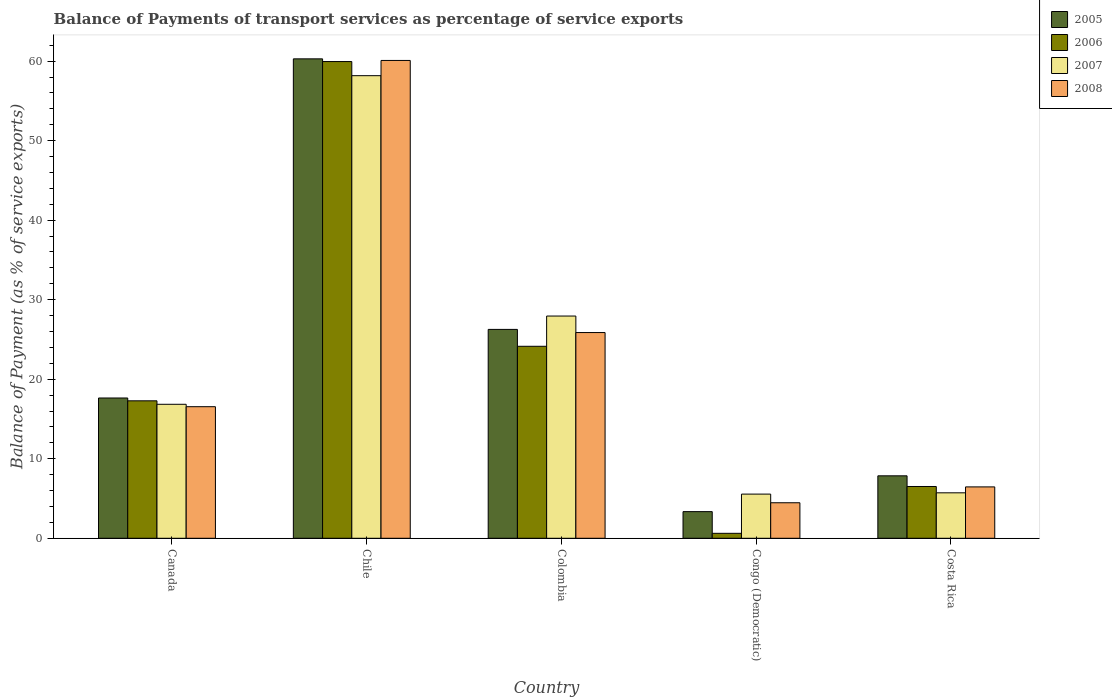How many different coloured bars are there?
Your answer should be very brief. 4. Are the number of bars per tick equal to the number of legend labels?
Keep it short and to the point. Yes. What is the balance of payments of transport services in 2006 in Colombia?
Your response must be concise. 24.14. Across all countries, what is the maximum balance of payments of transport services in 2006?
Make the answer very short. 59.94. Across all countries, what is the minimum balance of payments of transport services in 2006?
Make the answer very short. 0.62. In which country was the balance of payments of transport services in 2006 minimum?
Your answer should be very brief. Congo (Democratic). What is the total balance of payments of transport services in 2007 in the graph?
Make the answer very short. 114.23. What is the difference between the balance of payments of transport services in 2006 in Chile and that in Colombia?
Make the answer very short. 35.8. What is the difference between the balance of payments of transport services in 2006 in Congo (Democratic) and the balance of payments of transport services in 2005 in Chile?
Make the answer very short. -59.66. What is the average balance of payments of transport services in 2005 per country?
Your answer should be compact. 23.08. What is the difference between the balance of payments of transport services of/in 2008 and balance of payments of transport services of/in 2006 in Congo (Democratic)?
Ensure brevity in your answer.  3.84. In how many countries, is the balance of payments of transport services in 2006 greater than 32 %?
Keep it short and to the point. 1. What is the ratio of the balance of payments of transport services in 2008 in Chile to that in Colombia?
Give a very brief answer. 2.32. What is the difference between the highest and the second highest balance of payments of transport services in 2008?
Your answer should be very brief. -9.32. What is the difference between the highest and the lowest balance of payments of transport services in 2008?
Your response must be concise. 55.62. Is the sum of the balance of payments of transport services in 2007 in Congo (Democratic) and Costa Rica greater than the maximum balance of payments of transport services in 2005 across all countries?
Give a very brief answer. No. What does the 2nd bar from the left in Canada represents?
Ensure brevity in your answer.  2006. What does the 2nd bar from the right in Congo (Democratic) represents?
Your answer should be compact. 2007. Is it the case that in every country, the sum of the balance of payments of transport services in 2005 and balance of payments of transport services in 2008 is greater than the balance of payments of transport services in 2007?
Provide a succinct answer. Yes. How many bars are there?
Provide a succinct answer. 20. Are all the bars in the graph horizontal?
Provide a short and direct response. No. How many countries are there in the graph?
Make the answer very short. 5. What is the difference between two consecutive major ticks on the Y-axis?
Offer a terse response. 10. Are the values on the major ticks of Y-axis written in scientific E-notation?
Provide a short and direct response. No. Does the graph contain any zero values?
Your response must be concise. No. Where does the legend appear in the graph?
Your answer should be compact. Top right. How many legend labels are there?
Keep it short and to the point. 4. What is the title of the graph?
Ensure brevity in your answer.  Balance of Payments of transport services as percentage of service exports. What is the label or title of the X-axis?
Ensure brevity in your answer.  Country. What is the label or title of the Y-axis?
Provide a short and direct response. Balance of Payment (as % of service exports). What is the Balance of Payment (as % of service exports) of 2005 in Canada?
Your response must be concise. 17.64. What is the Balance of Payment (as % of service exports) of 2006 in Canada?
Your answer should be compact. 17.28. What is the Balance of Payment (as % of service exports) of 2007 in Canada?
Your answer should be very brief. 16.85. What is the Balance of Payment (as % of service exports) of 2008 in Canada?
Your response must be concise. 16.55. What is the Balance of Payment (as % of service exports) in 2005 in Chile?
Your response must be concise. 60.28. What is the Balance of Payment (as % of service exports) of 2006 in Chile?
Provide a short and direct response. 59.94. What is the Balance of Payment (as % of service exports) in 2007 in Chile?
Keep it short and to the point. 58.17. What is the Balance of Payment (as % of service exports) of 2008 in Chile?
Offer a very short reply. 60.08. What is the Balance of Payment (as % of service exports) in 2005 in Colombia?
Make the answer very short. 26.27. What is the Balance of Payment (as % of service exports) of 2006 in Colombia?
Give a very brief answer. 24.14. What is the Balance of Payment (as % of service exports) in 2007 in Colombia?
Offer a very short reply. 27.95. What is the Balance of Payment (as % of service exports) in 2008 in Colombia?
Provide a succinct answer. 25.87. What is the Balance of Payment (as % of service exports) in 2005 in Congo (Democratic)?
Offer a terse response. 3.35. What is the Balance of Payment (as % of service exports) in 2006 in Congo (Democratic)?
Offer a terse response. 0.62. What is the Balance of Payment (as % of service exports) in 2007 in Congo (Democratic)?
Give a very brief answer. 5.56. What is the Balance of Payment (as % of service exports) in 2008 in Congo (Democratic)?
Ensure brevity in your answer.  4.47. What is the Balance of Payment (as % of service exports) of 2005 in Costa Rica?
Provide a succinct answer. 7.85. What is the Balance of Payment (as % of service exports) in 2006 in Costa Rica?
Your answer should be very brief. 6.51. What is the Balance of Payment (as % of service exports) of 2007 in Costa Rica?
Your response must be concise. 5.72. What is the Balance of Payment (as % of service exports) in 2008 in Costa Rica?
Offer a very short reply. 6.46. Across all countries, what is the maximum Balance of Payment (as % of service exports) in 2005?
Make the answer very short. 60.28. Across all countries, what is the maximum Balance of Payment (as % of service exports) of 2006?
Offer a terse response. 59.94. Across all countries, what is the maximum Balance of Payment (as % of service exports) of 2007?
Give a very brief answer. 58.17. Across all countries, what is the maximum Balance of Payment (as % of service exports) of 2008?
Offer a very short reply. 60.08. Across all countries, what is the minimum Balance of Payment (as % of service exports) of 2005?
Provide a succinct answer. 3.35. Across all countries, what is the minimum Balance of Payment (as % of service exports) of 2006?
Offer a very short reply. 0.62. Across all countries, what is the minimum Balance of Payment (as % of service exports) in 2007?
Your answer should be very brief. 5.56. Across all countries, what is the minimum Balance of Payment (as % of service exports) of 2008?
Provide a short and direct response. 4.47. What is the total Balance of Payment (as % of service exports) of 2005 in the graph?
Your answer should be compact. 115.39. What is the total Balance of Payment (as % of service exports) in 2006 in the graph?
Your response must be concise. 108.5. What is the total Balance of Payment (as % of service exports) of 2007 in the graph?
Give a very brief answer. 114.23. What is the total Balance of Payment (as % of service exports) in 2008 in the graph?
Make the answer very short. 113.42. What is the difference between the Balance of Payment (as % of service exports) in 2005 in Canada and that in Chile?
Offer a very short reply. -42.64. What is the difference between the Balance of Payment (as % of service exports) of 2006 in Canada and that in Chile?
Give a very brief answer. -42.66. What is the difference between the Balance of Payment (as % of service exports) of 2007 in Canada and that in Chile?
Offer a terse response. -41.32. What is the difference between the Balance of Payment (as % of service exports) of 2008 in Canada and that in Chile?
Provide a succinct answer. -43.54. What is the difference between the Balance of Payment (as % of service exports) in 2005 in Canada and that in Colombia?
Offer a very short reply. -8.63. What is the difference between the Balance of Payment (as % of service exports) of 2006 in Canada and that in Colombia?
Your answer should be very brief. -6.86. What is the difference between the Balance of Payment (as % of service exports) of 2007 in Canada and that in Colombia?
Ensure brevity in your answer.  -11.1. What is the difference between the Balance of Payment (as % of service exports) in 2008 in Canada and that in Colombia?
Offer a very short reply. -9.32. What is the difference between the Balance of Payment (as % of service exports) of 2005 in Canada and that in Congo (Democratic)?
Your response must be concise. 14.29. What is the difference between the Balance of Payment (as % of service exports) in 2006 in Canada and that in Congo (Democratic)?
Offer a terse response. 16.66. What is the difference between the Balance of Payment (as % of service exports) of 2007 in Canada and that in Congo (Democratic)?
Provide a short and direct response. 11.29. What is the difference between the Balance of Payment (as % of service exports) in 2008 in Canada and that in Congo (Democratic)?
Your answer should be compact. 12.08. What is the difference between the Balance of Payment (as % of service exports) of 2005 in Canada and that in Costa Rica?
Your response must be concise. 9.79. What is the difference between the Balance of Payment (as % of service exports) of 2006 in Canada and that in Costa Rica?
Make the answer very short. 10.77. What is the difference between the Balance of Payment (as % of service exports) in 2007 in Canada and that in Costa Rica?
Your answer should be very brief. 11.13. What is the difference between the Balance of Payment (as % of service exports) of 2008 in Canada and that in Costa Rica?
Ensure brevity in your answer.  10.08. What is the difference between the Balance of Payment (as % of service exports) of 2005 in Chile and that in Colombia?
Ensure brevity in your answer.  34.02. What is the difference between the Balance of Payment (as % of service exports) in 2006 in Chile and that in Colombia?
Provide a succinct answer. 35.8. What is the difference between the Balance of Payment (as % of service exports) in 2007 in Chile and that in Colombia?
Give a very brief answer. 30.22. What is the difference between the Balance of Payment (as % of service exports) of 2008 in Chile and that in Colombia?
Offer a terse response. 34.22. What is the difference between the Balance of Payment (as % of service exports) of 2005 in Chile and that in Congo (Democratic)?
Provide a succinct answer. 56.93. What is the difference between the Balance of Payment (as % of service exports) of 2006 in Chile and that in Congo (Democratic)?
Offer a terse response. 59.32. What is the difference between the Balance of Payment (as % of service exports) of 2007 in Chile and that in Congo (Democratic)?
Provide a short and direct response. 52.61. What is the difference between the Balance of Payment (as % of service exports) of 2008 in Chile and that in Congo (Democratic)?
Ensure brevity in your answer.  55.62. What is the difference between the Balance of Payment (as % of service exports) in 2005 in Chile and that in Costa Rica?
Keep it short and to the point. 52.43. What is the difference between the Balance of Payment (as % of service exports) of 2006 in Chile and that in Costa Rica?
Ensure brevity in your answer.  53.43. What is the difference between the Balance of Payment (as % of service exports) in 2007 in Chile and that in Costa Rica?
Keep it short and to the point. 52.45. What is the difference between the Balance of Payment (as % of service exports) in 2008 in Chile and that in Costa Rica?
Your answer should be very brief. 53.62. What is the difference between the Balance of Payment (as % of service exports) in 2005 in Colombia and that in Congo (Democratic)?
Offer a very short reply. 22.91. What is the difference between the Balance of Payment (as % of service exports) of 2006 in Colombia and that in Congo (Democratic)?
Offer a terse response. 23.52. What is the difference between the Balance of Payment (as % of service exports) in 2007 in Colombia and that in Congo (Democratic)?
Provide a short and direct response. 22.39. What is the difference between the Balance of Payment (as % of service exports) in 2008 in Colombia and that in Congo (Democratic)?
Offer a very short reply. 21.4. What is the difference between the Balance of Payment (as % of service exports) of 2005 in Colombia and that in Costa Rica?
Offer a terse response. 18.41. What is the difference between the Balance of Payment (as % of service exports) of 2006 in Colombia and that in Costa Rica?
Your response must be concise. 17.63. What is the difference between the Balance of Payment (as % of service exports) of 2007 in Colombia and that in Costa Rica?
Keep it short and to the point. 22.23. What is the difference between the Balance of Payment (as % of service exports) of 2008 in Colombia and that in Costa Rica?
Keep it short and to the point. 19.41. What is the difference between the Balance of Payment (as % of service exports) of 2005 in Congo (Democratic) and that in Costa Rica?
Provide a succinct answer. -4.5. What is the difference between the Balance of Payment (as % of service exports) of 2006 in Congo (Democratic) and that in Costa Rica?
Offer a terse response. -5.89. What is the difference between the Balance of Payment (as % of service exports) of 2007 in Congo (Democratic) and that in Costa Rica?
Your answer should be very brief. -0.16. What is the difference between the Balance of Payment (as % of service exports) in 2008 in Congo (Democratic) and that in Costa Rica?
Keep it short and to the point. -1.99. What is the difference between the Balance of Payment (as % of service exports) in 2005 in Canada and the Balance of Payment (as % of service exports) in 2006 in Chile?
Provide a succinct answer. -42.3. What is the difference between the Balance of Payment (as % of service exports) in 2005 in Canada and the Balance of Payment (as % of service exports) in 2007 in Chile?
Provide a succinct answer. -40.53. What is the difference between the Balance of Payment (as % of service exports) of 2005 in Canada and the Balance of Payment (as % of service exports) of 2008 in Chile?
Offer a terse response. -42.44. What is the difference between the Balance of Payment (as % of service exports) in 2006 in Canada and the Balance of Payment (as % of service exports) in 2007 in Chile?
Keep it short and to the point. -40.88. What is the difference between the Balance of Payment (as % of service exports) of 2006 in Canada and the Balance of Payment (as % of service exports) of 2008 in Chile?
Provide a succinct answer. -42.8. What is the difference between the Balance of Payment (as % of service exports) in 2007 in Canada and the Balance of Payment (as % of service exports) in 2008 in Chile?
Keep it short and to the point. -43.24. What is the difference between the Balance of Payment (as % of service exports) of 2005 in Canada and the Balance of Payment (as % of service exports) of 2006 in Colombia?
Make the answer very short. -6.5. What is the difference between the Balance of Payment (as % of service exports) in 2005 in Canada and the Balance of Payment (as % of service exports) in 2007 in Colombia?
Provide a succinct answer. -10.31. What is the difference between the Balance of Payment (as % of service exports) in 2005 in Canada and the Balance of Payment (as % of service exports) in 2008 in Colombia?
Give a very brief answer. -8.23. What is the difference between the Balance of Payment (as % of service exports) in 2006 in Canada and the Balance of Payment (as % of service exports) in 2007 in Colombia?
Your answer should be compact. -10.66. What is the difference between the Balance of Payment (as % of service exports) in 2006 in Canada and the Balance of Payment (as % of service exports) in 2008 in Colombia?
Give a very brief answer. -8.58. What is the difference between the Balance of Payment (as % of service exports) of 2007 in Canada and the Balance of Payment (as % of service exports) of 2008 in Colombia?
Your answer should be compact. -9.02. What is the difference between the Balance of Payment (as % of service exports) in 2005 in Canada and the Balance of Payment (as % of service exports) in 2006 in Congo (Democratic)?
Your answer should be compact. 17.02. What is the difference between the Balance of Payment (as % of service exports) of 2005 in Canada and the Balance of Payment (as % of service exports) of 2007 in Congo (Democratic)?
Make the answer very short. 12.08. What is the difference between the Balance of Payment (as % of service exports) of 2005 in Canada and the Balance of Payment (as % of service exports) of 2008 in Congo (Democratic)?
Your response must be concise. 13.17. What is the difference between the Balance of Payment (as % of service exports) in 2006 in Canada and the Balance of Payment (as % of service exports) in 2007 in Congo (Democratic)?
Give a very brief answer. 11.73. What is the difference between the Balance of Payment (as % of service exports) in 2006 in Canada and the Balance of Payment (as % of service exports) in 2008 in Congo (Democratic)?
Make the answer very short. 12.82. What is the difference between the Balance of Payment (as % of service exports) in 2007 in Canada and the Balance of Payment (as % of service exports) in 2008 in Congo (Democratic)?
Provide a succinct answer. 12.38. What is the difference between the Balance of Payment (as % of service exports) of 2005 in Canada and the Balance of Payment (as % of service exports) of 2006 in Costa Rica?
Provide a short and direct response. 11.13. What is the difference between the Balance of Payment (as % of service exports) in 2005 in Canada and the Balance of Payment (as % of service exports) in 2007 in Costa Rica?
Keep it short and to the point. 11.92. What is the difference between the Balance of Payment (as % of service exports) in 2005 in Canada and the Balance of Payment (as % of service exports) in 2008 in Costa Rica?
Give a very brief answer. 11.18. What is the difference between the Balance of Payment (as % of service exports) of 2006 in Canada and the Balance of Payment (as % of service exports) of 2007 in Costa Rica?
Provide a short and direct response. 11.57. What is the difference between the Balance of Payment (as % of service exports) in 2006 in Canada and the Balance of Payment (as % of service exports) in 2008 in Costa Rica?
Keep it short and to the point. 10.82. What is the difference between the Balance of Payment (as % of service exports) in 2007 in Canada and the Balance of Payment (as % of service exports) in 2008 in Costa Rica?
Give a very brief answer. 10.39. What is the difference between the Balance of Payment (as % of service exports) in 2005 in Chile and the Balance of Payment (as % of service exports) in 2006 in Colombia?
Provide a succinct answer. 36.14. What is the difference between the Balance of Payment (as % of service exports) of 2005 in Chile and the Balance of Payment (as % of service exports) of 2007 in Colombia?
Your answer should be compact. 32.34. What is the difference between the Balance of Payment (as % of service exports) of 2005 in Chile and the Balance of Payment (as % of service exports) of 2008 in Colombia?
Your answer should be very brief. 34.42. What is the difference between the Balance of Payment (as % of service exports) of 2006 in Chile and the Balance of Payment (as % of service exports) of 2007 in Colombia?
Your answer should be very brief. 32. What is the difference between the Balance of Payment (as % of service exports) in 2006 in Chile and the Balance of Payment (as % of service exports) in 2008 in Colombia?
Offer a terse response. 34.08. What is the difference between the Balance of Payment (as % of service exports) of 2007 in Chile and the Balance of Payment (as % of service exports) of 2008 in Colombia?
Make the answer very short. 32.3. What is the difference between the Balance of Payment (as % of service exports) of 2005 in Chile and the Balance of Payment (as % of service exports) of 2006 in Congo (Democratic)?
Ensure brevity in your answer.  59.66. What is the difference between the Balance of Payment (as % of service exports) in 2005 in Chile and the Balance of Payment (as % of service exports) in 2007 in Congo (Democratic)?
Provide a short and direct response. 54.73. What is the difference between the Balance of Payment (as % of service exports) of 2005 in Chile and the Balance of Payment (as % of service exports) of 2008 in Congo (Democratic)?
Your answer should be compact. 55.82. What is the difference between the Balance of Payment (as % of service exports) of 2006 in Chile and the Balance of Payment (as % of service exports) of 2007 in Congo (Democratic)?
Give a very brief answer. 54.39. What is the difference between the Balance of Payment (as % of service exports) of 2006 in Chile and the Balance of Payment (as % of service exports) of 2008 in Congo (Democratic)?
Keep it short and to the point. 55.48. What is the difference between the Balance of Payment (as % of service exports) of 2007 in Chile and the Balance of Payment (as % of service exports) of 2008 in Congo (Democratic)?
Offer a terse response. 53.7. What is the difference between the Balance of Payment (as % of service exports) of 2005 in Chile and the Balance of Payment (as % of service exports) of 2006 in Costa Rica?
Keep it short and to the point. 53.77. What is the difference between the Balance of Payment (as % of service exports) of 2005 in Chile and the Balance of Payment (as % of service exports) of 2007 in Costa Rica?
Ensure brevity in your answer.  54.57. What is the difference between the Balance of Payment (as % of service exports) of 2005 in Chile and the Balance of Payment (as % of service exports) of 2008 in Costa Rica?
Your answer should be very brief. 53.82. What is the difference between the Balance of Payment (as % of service exports) in 2006 in Chile and the Balance of Payment (as % of service exports) in 2007 in Costa Rica?
Offer a very short reply. 54.23. What is the difference between the Balance of Payment (as % of service exports) in 2006 in Chile and the Balance of Payment (as % of service exports) in 2008 in Costa Rica?
Provide a succinct answer. 53.48. What is the difference between the Balance of Payment (as % of service exports) in 2007 in Chile and the Balance of Payment (as % of service exports) in 2008 in Costa Rica?
Give a very brief answer. 51.71. What is the difference between the Balance of Payment (as % of service exports) in 2005 in Colombia and the Balance of Payment (as % of service exports) in 2006 in Congo (Democratic)?
Keep it short and to the point. 25.64. What is the difference between the Balance of Payment (as % of service exports) in 2005 in Colombia and the Balance of Payment (as % of service exports) in 2007 in Congo (Democratic)?
Provide a short and direct response. 20.71. What is the difference between the Balance of Payment (as % of service exports) of 2005 in Colombia and the Balance of Payment (as % of service exports) of 2008 in Congo (Democratic)?
Provide a succinct answer. 21.8. What is the difference between the Balance of Payment (as % of service exports) of 2006 in Colombia and the Balance of Payment (as % of service exports) of 2007 in Congo (Democratic)?
Offer a very short reply. 18.59. What is the difference between the Balance of Payment (as % of service exports) in 2006 in Colombia and the Balance of Payment (as % of service exports) in 2008 in Congo (Democratic)?
Your answer should be very brief. 19.67. What is the difference between the Balance of Payment (as % of service exports) in 2007 in Colombia and the Balance of Payment (as % of service exports) in 2008 in Congo (Democratic)?
Your response must be concise. 23.48. What is the difference between the Balance of Payment (as % of service exports) in 2005 in Colombia and the Balance of Payment (as % of service exports) in 2006 in Costa Rica?
Your response must be concise. 19.75. What is the difference between the Balance of Payment (as % of service exports) in 2005 in Colombia and the Balance of Payment (as % of service exports) in 2007 in Costa Rica?
Provide a short and direct response. 20.55. What is the difference between the Balance of Payment (as % of service exports) in 2005 in Colombia and the Balance of Payment (as % of service exports) in 2008 in Costa Rica?
Provide a short and direct response. 19.8. What is the difference between the Balance of Payment (as % of service exports) in 2006 in Colombia and the Balance of Payment (as % of service exports) in 2007 in Costa Rica?
Give a very brief answer. 18.42. What is the difference between the Balance of Payment (as % of service exports) in 2006 in Colombia and the Balance of Payment (as % of service exports) in 2008 in Costa Rica?
Ensure brevity in your answer.  17.68. What is the difference between the Balance of Payment (as % of service exports) of 2007 in Colombia and the Balance of Payment (as % of service exports) of 2008 in Costa Rica?
Give a very brief answer. 21.48. What is the difference between the Balance of Payment (as % of service exports) of 2005 in Congo (Democratic) and the Balance of Payment (as % of service exports) of 2006 in Costa Rica?
Provide a short and direct response. -3.16. What is the difference between the Balance of Payment (as % of service exports) of 2005 in Congo (Democratic) and the Balance of Payment (as % of service exports) of 2007 in Costa Rica?
Keep it short and to the point. -2.37. What is the difference between the Balance of Payment (as % of service exports) of 2005 in Congo (Democratic) and the Balance of Payment (as % of service exports) of 2008 in Costa Rica?
Your answer should be compact. -3.11. What is the difference between the Balance of Payment (as % of service exports) of 2006 in Congo (Democratic) and the Balance of Payment (as % of service exports) of 2007 in Costa Rica?
Ensure brevity in your answer.  -5.09. What is the difference between the Balance of Payment (as % of service exports) of 2006 in Congo (Democratic) and the Balance of Payment (as % of service exports) of 2008 in Costa Rica?
Offer a very short reply. -5.84. What is the difference between the Balance of Payment (as % of service exports) in 2007 in Congo (Democratic) and the Balance of Payment (as % of service exports) in 2008 in Costa Rica?
Provide a succinct answer. -0.91. What is the average Balance of Payment (as % of service exports) in 2005 per country?
Offer a terse response. 23.08. What is the average Balance of Payment (as % of service exports) of 2006 per country?
Offer a terse response. 21.7. What is the average Balance of Payment (as % of service exports) of 2007 per country?
Offer a terse response. 22.85. What is the average Balance of Payment (as % of service exports) of 2008 per country?
Provide a succinct answer. 22.68. What is the difference between the Balance of Payment (as % of service exports) in 2005 and Balance of Payment (as % of service exports) in 2006 in Canada?
Offer a very short reply. 0.36. What is the difference between the Balance of Payment (as % of service exports) of 2005 and Balance of Payment (as % of service exports) of 2007 in Canada?
Your response must be concise. 0.79. What is the difference between the Balance of Payment (as % of service exports) in 2005 and Balance of Payment (as % of service exports) in 2008 in Canada?
Keep it short and to the point. 1.09. What is the difference between the Balance of Payment (as % of service exports) of 2006 and Balance of Payment (as % of service exports) of 2007 in Canada?
Make the answer very short. 0.44. What is the difference between the Balance of Payment (as % of service exports) of 2006 and Balance of Payment (as % of service exports) of 2008 in Canada?
Your response must be concise. 0.74. What is the difference between the Balance of Payment (as % of service exports) in 2007 and Balance of Payment (as % of service exports) in 2008 in Canada?
Make the answer very short. 0.3. What is the difference between the Balance of Payment (as % of service exports) in 2005 and Balance of Payment (as % of service exports) in 2006 in Chile?
Make the answer very short. 0.34. What is the difference between the Balance of Payment (as % of service exports) in 2005 and Balance of Payment (as % of service exports) in 2007 in Chile?
Offer a very short reply. 2.12. What is the difference between the Balance of Payment (as % of service exports) of 2005 and Balance of Payment (as % of service exports) of 2008 in Chile?
Offer a very short reply. 0.2. What is the difference between the Balance of Payment (as % of service exports) of 2006 and Balance of Payment (as % of service exports) of 2007 in Chile?
Offer a very short reply. 1.78. What is the difference between the Balance of Payment (as % of service exports) in 2006 and Balance of Payment (as % of service exports) in 2008 in Chile?
Your answer should be compact. -0.14. What is the difference between the Balance of Payment (as % of service exports) of 2007 and Balance of Payment (as % of service exports) of 2008 in Chile?
Your response must be concise. -1.92. What is the difference between the Balance of Payment (as % of service exports) of 2005 and Balance of Payment (as % of service exports) of 2006 in Colombia?
Ensure brevity in your answer.  2.12. What is the difference between the Balance of Payment (as % of service exports) of 2005 and Balance of Payment (as % of service exports) of 2007 in Colombia?
Make the answer very short. -1.68. What is the difference between the Balance of Payment (as % of service exports) in 2005 and Balance of Payment (as % of service exports) in 2008 in Colombia?
Your answer should be very brief. 0.4. What is the difference between the Balance of Payment (as % of service exports) of 2006 and Balance of Payment (as % of service exports) of 2007 in Colombia?
Provide a succinct answer. -3.8. What is the difference between the Balance of Payment (as % of service exports) in 2006 and Balance of Payment (as % of service exports) in 2008 in Colombia?
Offer a very short reply. -1.73. What is the difference between the Balance of Payment (as % of service exports) of 2007 and Balance of Payment (as % of service exports) of 2008 in Colombia?
Your answer should be compact. 2.08. What is the difference between the Balance of Payment (as % of service exports) in 2005 and Balance of Payment (as % of service exports) in 2006 in Congo (Democratic)?
Provide a short and direct response. 2.73. What is the difference between the Balance of Payment (as % of service exports) of 2005 and Balance of Payment (as % of service exports) of 2007 in Congo (Democratic)?
Give a very brief answer. -2.2. What is the difference between the Balance of Payment (as % of service exports) in 2005 and Balance of Payment (as % of service exports) in 2008 in Congo (Democratic)?
Provide a succinct answer. -1.12. What is the difference between the Balance of Payment (as % of service exports) of 2006 and Balance of Payment (as % of service exports) of 2007 in Congo (Democratic)?
Your answer should be very brief. -4.93. What is the difference between the Balance of Payment (as % of service exports) of 2006 and Balance of Payment (as % of service exports) of 2008 in Congo (Democratic)?
Your response must be concise. -3.84. What is the difference between the Balance of Payment (as % of service exports) of 2007 and Balance of Payment (as % of service exports) of 2008 in Congo (Democratic)?
Your answer should be compact. 1.09. What is the difference between the Balance of Payment (as % of service exports) of 2005 and Balance of Payment (as % of service exports) of 2006 in Costa Rica?
Give a very brief answer. 1.34. What is the difference between the Balance of Payment (as % of service exports) of 2005 and Balance of Payment (as % of service exports) of 2007 in Costa Rica?
Offer a very short reply. 2.14. What is the difference between the Balance of Payment (as % of service exports) in 2005 and Balance of Payment (as % of service exports) in 2008 in Costa Rica?
Your answer should be compact. 1.39. What is the difference between the Balance of Payment (as % of service exports) of 2006 and Balance of Payment (as % of service exports) of 2007 in Costa Rica?
Your response must be concise. 0.79. What is the difference between the Balance of Payment (as % of service exports) of 2006 and Balance of Payment (as % of service exports) of 2008 in Costa Rica?
Offer a terse response. 0.05. What is the difference between the Balance of Payment (as % of service exports) in 2007 and Balance of Payment (as % of service exports) in 2008 in Costa Rica?
Your response must be concise. -0.74. What is the ratio of the Balance of Payment (as % of service exports) of 2005 in Canada to that in Chile?
Ensure brevity in your answer.  0.29. What is the ratio of the Balance of Payment (as % of service exports) of 2006 in Canada to that in Chile?
Provide a succinct answer. 0.29. What is the ratio of the Balance of Payment (as % of service exports) of 2007 in Canada to that in Chile?
Keep it short and to the point. 0.29. What is the ratio of the Balance of Payment (as % of service exports) of 2008 in Canada to that in Chile?
Provide a succinct answer. 0.28. What is the ratio of the Balance of Payment (as % of service exports) in 2005 in Canada to that in Colombia?
Your answer should be compact. 0.67. What is the ratio of the Balance of Payment (as % of service exports) in 2006 in Canada to that in Colombia?
Offer a terse response. 0.72. What is the ratio of the Balance of Payment (as % of service exports) of 2007 in Canada to that in Colombia?
Provide a succinct answer. 0.6. What is the ratio of the Balance of Payment (as % of service exports) in 2008 in Canada to that in Colombia?
Provide a short and direct response. 0.64. What is the ratio of the Balance of Payment (as % of service exports) of 2005 in Canada to that in Congo (Democratic)?
Your answer should be very brief. 5.26. What is the ratio of the Balance of Payment (as % of service exports) in 2006 in Canada to that in Congo (Democratic)?
Make the answer very short. 27.71. What is the ratio of the Balance of Payment (as % of service exports) in 2007 in Canada to that in Congo (Democratic)?
Offer a terse response. 3.03. What is the ratio of the Balance of Payment (as % of service exports) in 2008 in Canada to that in Congo (Democratic)?
Your answer should be compact. 3.7. What is the ratio of the Balance of Payment (as % of service exports) in 2005 in Canada to that in Costa Rica?
Offer a terse response. 2.25. What is the ratio of the Balance of Payment (as % of service exports) in 2006 in Canada to that in Costa Rica?
Your answer should be compact. 2.65. What is the ratio of the Balance of Payment (as % of service exports) of 2007 in Canada to that in Costa Rica?
Provide a short and direct response. 2.95. What is the ratio of the Balance of Payment (as % of service exports) of 2008 in Canada to that in Costa Rica?
Ensure brevity in your answer.  2.56. What is the ratio of the Balance of Payment (as % of service exports) of 2005 in Chile to that in Colombia?
Your answer should be compact. 2.3. What is the ratio of the Balance of Payment (as % of service exports) of 2006 in Chile to that in Colombia?
Your response must be concise. 2.48. What is the ratio of the Balance of Payment (as % of service exports) in 2007 in Chile to that in Colombia?
Provide a succinct answer. 2.08. What is the ratio of the Balance of Payment (as % of service exports) in 2008 in Chile to that in Colombia?
Keep it short and to the point. 2.32. What is the ratio of the Balance of Payment (as % of service exports) in 2005 in Chile to that in Congo (Democratic)?
Your answer should be compact. 17.99. What is the ratio of the Balance of Payment (as % of service exports) of 2006 in Chile to that in Congo (Democratic)?
Provide a succinct answer. 96.11. What is the ratio of the Balance of Payment (as % of service exports) in 2007 in Chile to that in Congo (Democratic)?
Give a very brief answer. 10.47. What is the ratio of the Balance of Payment (as % of service exports) of 2008 in Chile to that in Congo (Democratic)?
Your answer should be compact. 13.45. What is the ratio of the Balance of Payment (as % of service exports) of 2005 in Chile to that in Costa Rica?
Give a very brief answer. 7.68. What is the ratio of the Balance of Payment (as % of service exports) of 2006 in Chile to that in Costa Rica?
Provide a succinct answer. 9.21. What is the ratio of the Balance of Payment (as % of service exports) in 2007 in Chile to that in Costa Rica?
Ensure brevity in your answer.  10.17. What is the ratio of the Balance of Payment (as % of service exports) in 2008 in Chile to that in Costa Rica?
Provide a succinct answer. 9.3. What is the ratio of the Balance of Payment (as % of service exports) in 2005 in Colombia to that in Congo (Democratic)?
Make the answer very short. 7.84. What is the ratio of the Balance of Payment (as % of service exports) of 2006 in Colombia to that in Congo (Democratic)?
Make the answer very short. 38.71. What is the ratio of the Balance of Payment (as % of service exports) in 2007 in Colombia to that in Congo (Democratic)?
Provide a succinct answer. 5.03. What is the ratio of the Balance of Payment (as % of service exports) in 2008 in Colombia to that in Congo (Democratic)?
Offer a terse response. 5.79. What is the ratio of the Balance of Payment (as % of service exports) in 2005 in Colombia to that in Costa Rica?
Your response must be concise. 3.34. What is the ratio of the Balance of Payment (as % of service exports) in 2006 in Colombia to that in Costa Rica?
Keep it short and to the point. 3.71. What is the ratio of the Balance of Payment (as % of service exports) of 2007 in Colombia to that in Costa Rica?
Offer a very short reply. 4.89. What is the ratio of the Balance of Payment (as % of service exports) of 2008 in Colombia to that in Costa Rica?
Offer a terse response. 4. What is the ratio of the Balance of Payment (as % of service exports) in 2005 in Congo (Democratic) to that in Costa Rica?
Keep it short and to the point. 0.43. What is the ratio of the Balance of Payment (as % of service exports) in 2006 in Congo (Democratic) to that in Costa Rica?
Provide a succinct answer. 0.1. What is the ratio of the Balance of Payment (as % of service exports) of 2007 in Congo (Democratic) to that in Costa Rica?
Your answer should be very brief. 0.97. What is the ratio of the Balance of Payment (as % of service exports) of 2008 in Congo (Democratic) to that in Costa Rica?
Your answer should be compact. 0.69. What is the difference between the highest and the second highest Balance of Payment (as % of service exports) of 2005?
Offer a very short reply. 34.02. What is the difference between the highest and the second highest Balance of Payment (as % of service exports) in 2006?
Provide a succinct answer. 35.8. What is the difference between the highest and the second highest Balance of Payment (as % of service exports) of 2007?
Ensure brevity in your answer.  30.22. What is the difference between the highest and the second highest Balance of Payment (as % of service exports) of 2008?
Keep it short and to the point. 34.22. What is the difference between the highest and the lowest Balance of Payment (as % of service exports) of 2005?
Offer a terse response. 56.93. What is the difference between the highest and the lowest Balance of Payment (as % of service exports) of 2006?
Offer a terse response. 59.32. What is the difference between the highest and the lowest Balance of Payment (as % of service exports) of 2007?
Your answer should be very brief. 52.61. What is the difference between the highest and the lowest Balance of Payment (as % of service exports) in 2008?
Give a very brief answer. 55.62. 